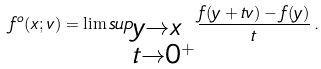Convert formula to latex. <formula><loc_0><loc_0><loc_500><loc_500>f ^ { o } ( x ; v ) = \lim s u p _ { \begin{subarray} { l } y \rightarrow x \\ t \rightarrow 0 ^ { + } \end{subarray} } \frac { f ( y + t v ) - f ( y ) } { t } \, .</formula> 